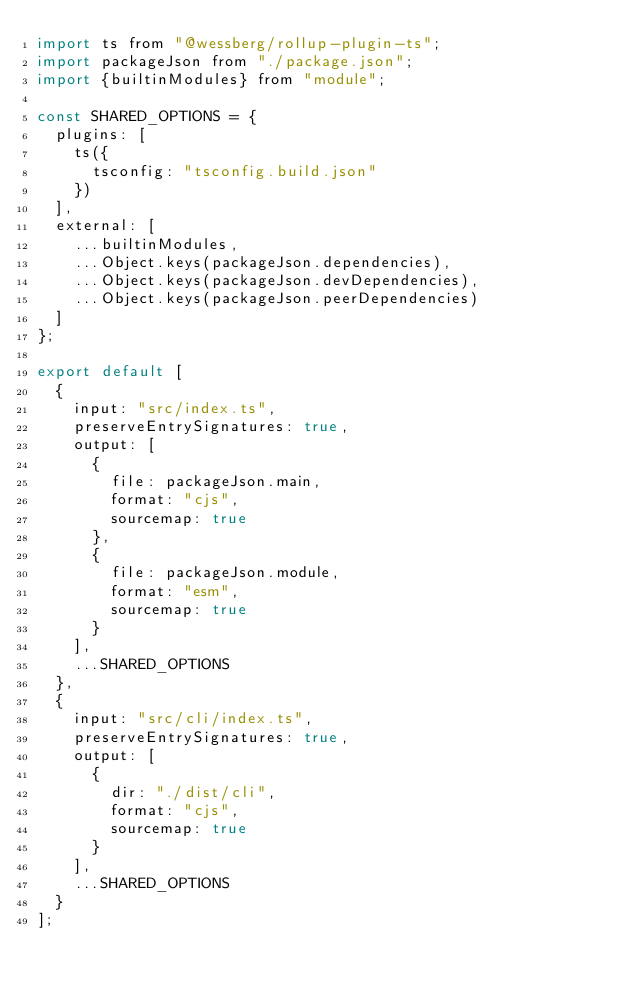Convert code to text. <code><loc_0><loc_0><loc_500><loc_500><_JavaScript_>import ts from "@wessberg/rollup-plugin-ts";
import packageJson from "./package.json";
import {builtinModules} from "module";

const SHARED_OPTIONS = {
	plugins: [
		ts({
			tsconfig: "tsconfig.build.json"
		})
	],
	external: [
		...builtinModules,
		...Object.keys(packageJson.dependencies),
		...Object.keys(packageJson.devDependencies),
		...Object.keys(packageJson.peerDependencies)
	]
};

export default [
	{
		input: "src/index.ts",
		preserveEntrySignatures: true,
		output: [
			{
				file: packageJson.main,
				format: "cjs",
				sourcemap: true
			},
			{
				file: packageJson.module,
				format: "esm",
				sourcemap: true
			}
		],
		...SHARED_OPTIONS
	},
	{
		input: "src/cli/index.ts",
		preserveEntrySignatures: true,
		output: [
			{
				dir: "./dist/cli",
				format: "cjs",
				sourcemap: true
			}
		],
		...SHARED_OPTIONS
	}
];
</code> 